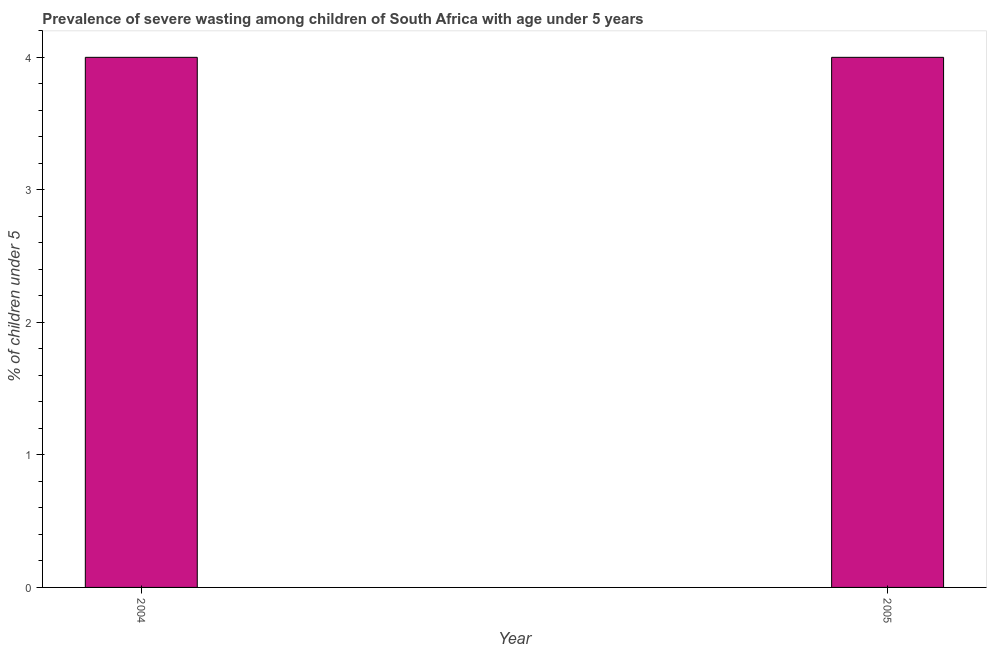Does the graph contain grids?
Keep it short and to the point. No. What is the title of the graph?
Your response must be concise. Prevalence of severe wasting among children of South Africa with age under 5 years. What is the label or title of the Y-axis?
Your answer should be compact.  % of children under 5. What is the prevalence of severe wasting in 2005?
Provide a short and direct response. 4. Across all years, what is the maximum prevalence of severe wasting?
Offer a terse response. 4. In which year was the prevalence of severe wasting maximum?
Your response must be concise. 2004. What is the sum of the prevalence of severe wasting?
Your response must be concise. 8. Do a majority of the years between 2004 and 2005 (inclusive) have prevalence of severe wasting greater than 1.4 %?
Offer a terse response. Yes. Is the prevalence of severe wasting in 2004 less than that in 2005?
Give a very brief answer. No. How many years are there in the graph?
Make the answer very short. 2. What is the  % of children under 5 in 2005?
Keep it short and to the point. 4. What is the difference between the  % of children under 5 in 2004 and 2005?
Ensure brevity in your answer.  0. 